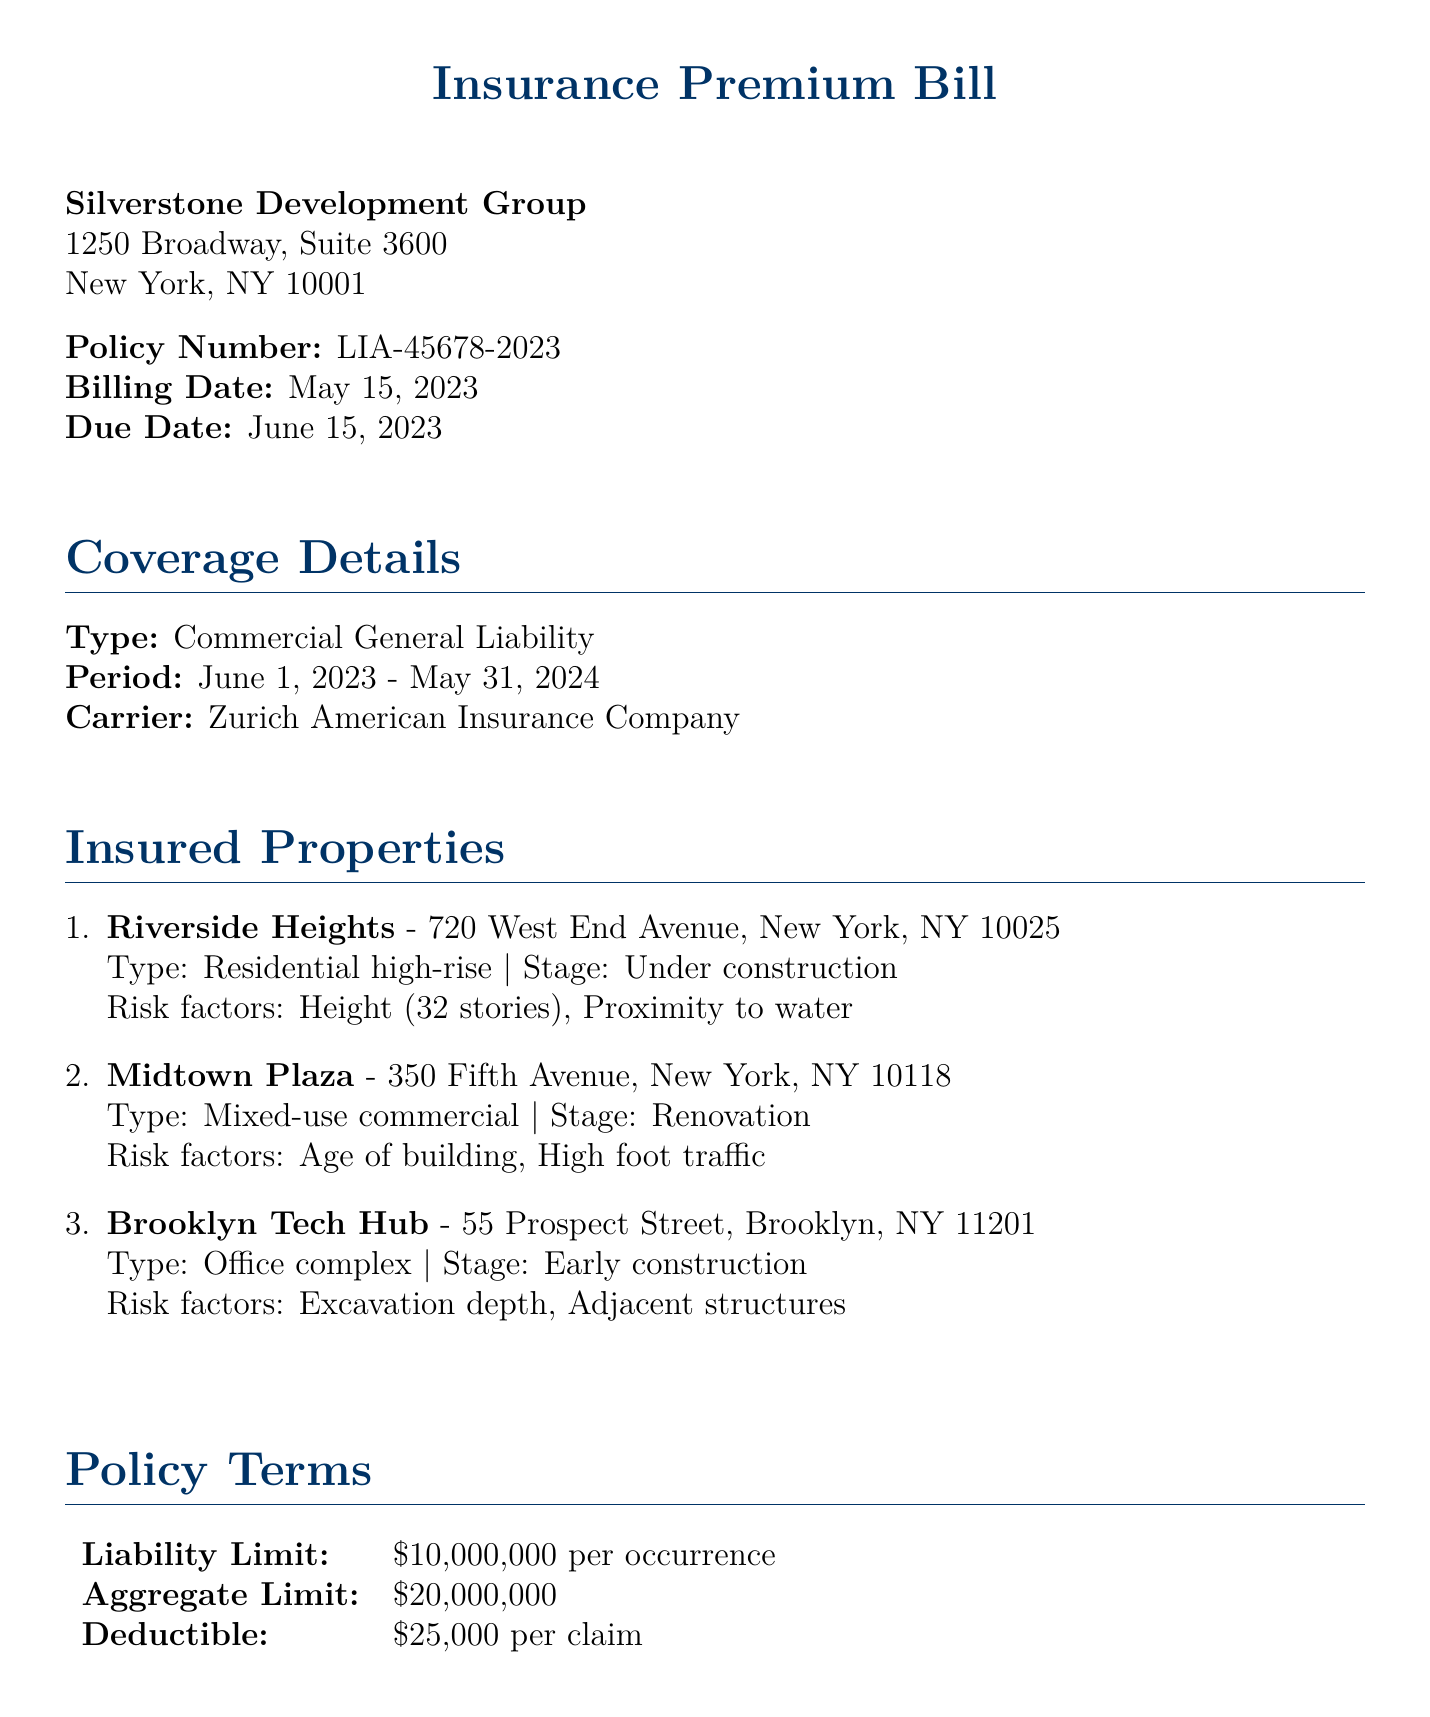What is the policy number? The policy number is stated in the document, identifying the insurance policy related to the bill.
Answer: LIA-45678-2023 What is the total premium amount? The total premium amount is calculated from the various components listed in the premium breakdown section.
Answer: $770,000 What is the deductible per claim? The deductible amount specifies how much needs to be paid out of pocket before the insurance coverage kicks in for claims.
Answer: $25,000 What is the liability limit per occurrence? The liability limit states the maximum amount the insurance will pay for a single claim.
Answer: $10,000,000 How many insured properties are listed? The document enumerates the insured properties, showcasing the total included in the coverage.
Answer: 3 What is the due date for payment? The due date is specified in the document as the deadline for making the premium payment.
Answer: June 15, 2023 Which insurance carrier is mentioned? The document identifies the company providing the insurance coverage for the properties.
Answer: Zurich American Insurance Company What are the payment options available? The document outlines the two options available for payment of the premium, reflecting flexibility for the insured party.
Answer: Full Payment and Quarterly Installments 